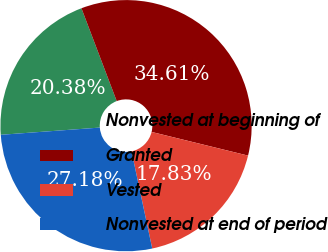Convert chart. <chart><loc_0><loc_0><loc_500><loc_500><pie_chart><fcel>Nonvested at beginning of<fcel>Granted<fcel>Vested<fcel>Nonvested at end of period<nl><fcel>20.38%<fcel>34.61%<fcel>17.83%<fcel>27.18%<nl></chart> 